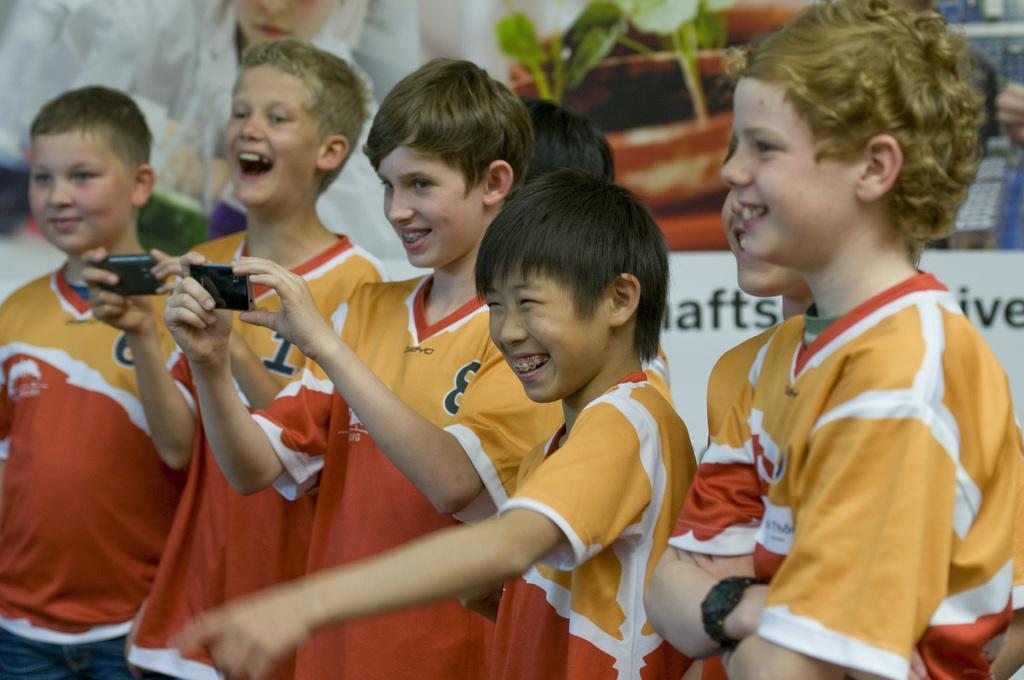<image>
Write a terse but informative summary of the picture. A group of young boys with number eight one and six 